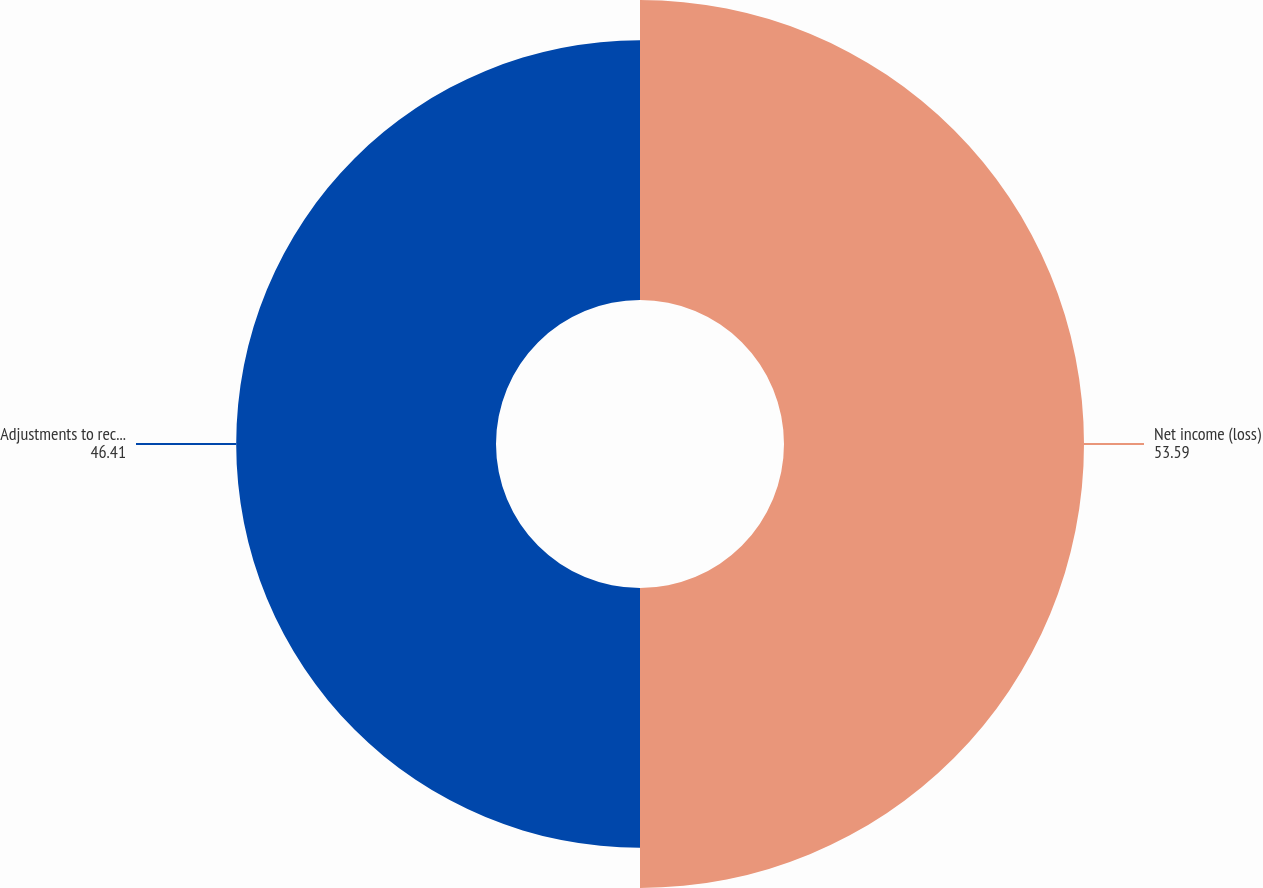<chart> <loc_0><loc_0><loc_500><loc_500><pie_chart><fcel>Net income (loss)<fcel>Adjustments to reconcile net<nl><fcel>53.59%<fcel>46.41%<nl></chart> 